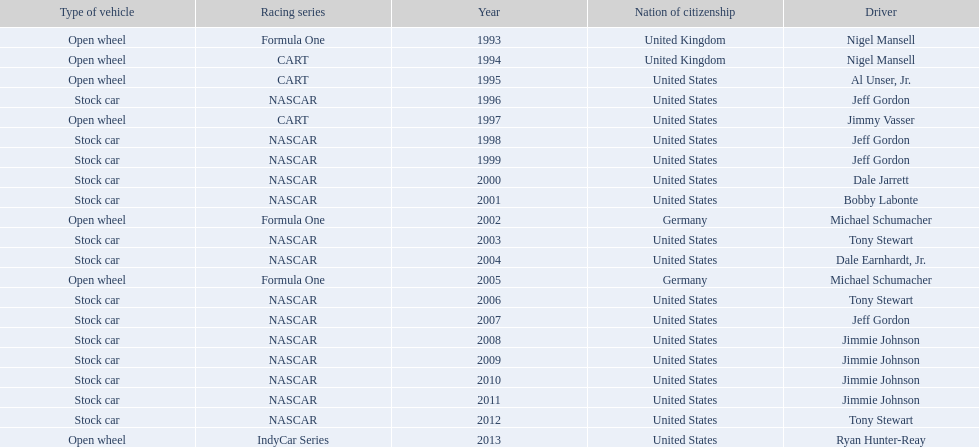What year(s) did nigel mansel receive epsy awards? 1993, 1994. What year(s) did michael schumacher receive epsy awards? 2002, 2005. What year(s) did jeff gordon receive epsy awards? 1996, 1998, 1999, 2007. What year(s) did al unser jr. receive epsy awards? 1995. Which driver only received one epsy award? Al Unser, Jr. 